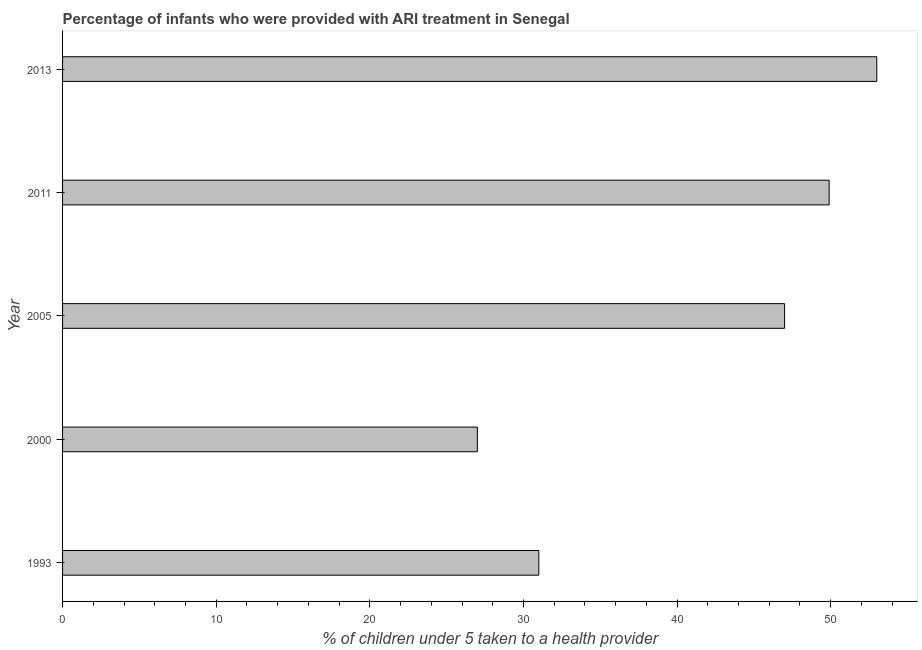What is the title of the graph?
Provide a succinct answer. Percentage of infants who were provided with ARI treatment in Senegal. What is the label or title of the X-axis?
Offer a very short reply. % of children under 5 taken to a health provider. What is the label or title of the Y-axis?
Your response must be concise. Year. What is the percentage of children who were provided with ari treatment in 2000?
Offer a terse response. 27. Across all years, what is the minimum percentage of children who were provided with ari treatment?
Give a very brief answer. 27. In which year was the percentage of children who were provided with ari treatment maximum?
Ensure brevity in your answer.  2013. What is the sum of the percentage of children who were provided with ari treatment?
Your response must be concise. 207.9. What is the difference between the percentage of children who were provided with ari treatment in 1993 and 2011?
Offer a terse response. -18.9. What is the average percentage of children who were provided with ari treatment per year?
Keep it short and to the point. 41.58. Do a majority of the years between 2000 and 2011 (inclusive) have percentage of children who were provided with ari treatment greater than 6 %?
Keep it short and to the point. Yes. What is the ratio of the percentage of children who were provided with ari treatment in 1993 to that in 2005?
Offer a terse response. 0.66. Is the percentage of children who were provided with ari treatment in 1993 less than that in 2011?
Make the answer very short. Yes. What is the difference between the highest and the second highest percentage of children who were provided with ari treatment?
Ensure brevity in your answer.  3.1. Is the sum of the percentage of children who were provided with ari treatment in 1993 and 2005 greater than the maximum percentage of children who were provided with ari treatment across all years?
Ensure brevity in your answer.  Yes. How many bars are there?
Provide a short and direct response. 5. How many years are there in the graph?
Ensure brevity in your answer.  5. What is the % of children under 5 taken to a health provider in 2011?
Ensure brevity in your answer.  49.9. What is the difference between the % of children under 5 taken to a health provider in 1993 and 2000?
Provide a short and direct response. 4. What is the difference between the % of children under 5 taken to a health provider in 1993 and 2011?
Provide a succinct answer. -18.9. What is the difference between the % of children under 5 taken to a health provider in 2000 and 2005?
Your answer should be very brief. -20. What is the difference between the % of children under 5 taken to a health provider in 2000 and 2011?
Provide a succinct answer. -22.9. What is the difference between the % of children under 5 taken to a health provider in 2005 and 2011?
Your response must be concise. -2.9. What is the ratio of the % of children under 5 taken to a health provider in 1993 to that in 2000?
Offer a very short reply. 1.15. What is the ratio of the % of children under 5 taken to a health provider in 1993 to that in 2005?
Ensure brevity in your answer.  0.66. What is the ratio of the % of children under 5 taken to a health provider in 1993 to that in 2011?
Make the answer very short. 0.62. What is the ratio of the % of children under 5 taken to a health provider in 1993 to that in 2013?
Provide a short and direct response. 0.58. What is the ratio of the % of children under 5 taken to a health provider in 2000 to that in 2005?
Provide a short and direct response. 0.57. What is the ratio of the % of children under 5 taken to a health provider in 2000 to that in 2011?
Provide a succinct answer. 0.54. What is the ratio of the % of children under 5 taken to a health provider in 2000 to that in 2013?
Ensure brevity in your answer.  0.51. What is the ratio of the % of children under 5 taken to a health provider in 2005 to that in 2011?
Your answer should be compact. 0.94. What is the ratio of the % of children under 5 taken to a health provider in 2005 to that in 2013?
Provide a short and direct response. 0.89. What is the ratio of the % of children under 5 taken to a health provider in 2011 to that in 2013?
Offer a very short reply. 0.94. 